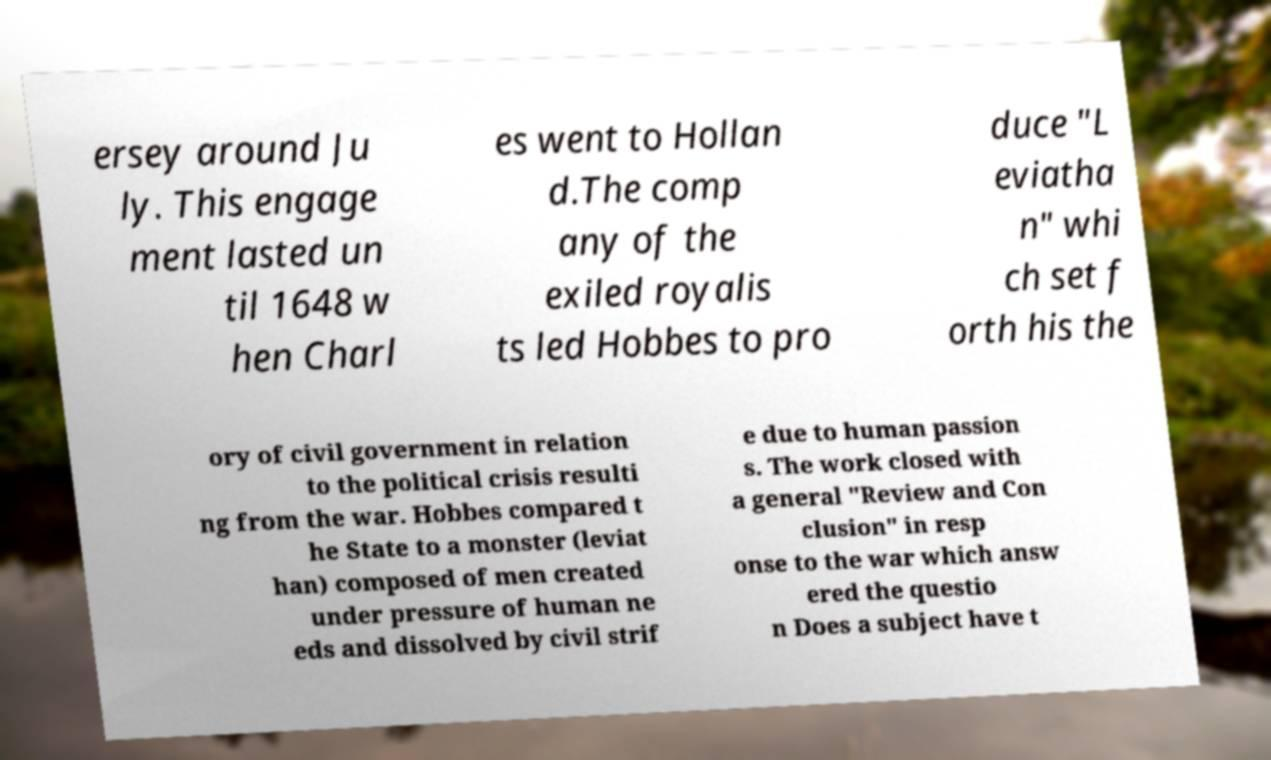For documentation purposes, I need the text within this image transcribed. Could you provide that? ersey around Ju ly. This engage ment lasted un til 1648 w hen Charl es went to Hollan d.The comp any of the exiled royalis ts led Hobbes to pro duce "L eviatha n" whi ch set f orth his the ory of civil government in relation to the political crisis resulti ng from the war. Hobbes compared t he State to a monster (leviat han) composed of men created under pressure of human ne eds and dissolved by civil strif e due to human passion s. The work closed with a general "Review and Con clusion" in resp onse to the war which answ ered the questio n Does a subject have t 